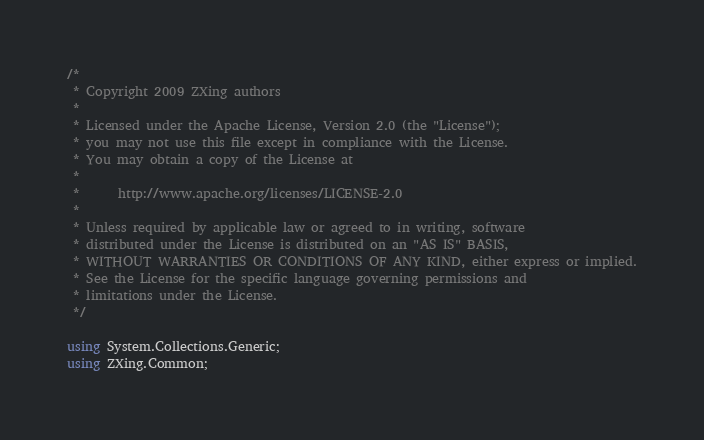Convert code to text. <code><loc_0><loc_0><loc_500><loc_500><_C#_>/*
 * Copyright 2009 ZXing authors
 *
 * Licensed under the Apache License, Version 2.0 (the "License");
 * you may not use this file except in compliance with the License.
 * You may obtain a copy of the License at
 *
 *      http://www.apache.org/licenses/LICENSE-2.0
 *
 * Unless required by applicable law or agreed to in writing, software
 * distributed under the License is distributed on an "AS IS" BASIS,
 * WITHOUT WARRANTIES OR CONDITIONS OF ANY KIND, either express or implied.
 * See the License for the specific language governing permissions and
 * limitations under the License.
 */

using System.Collections.Generic;
using ZXing.Common;</code> 